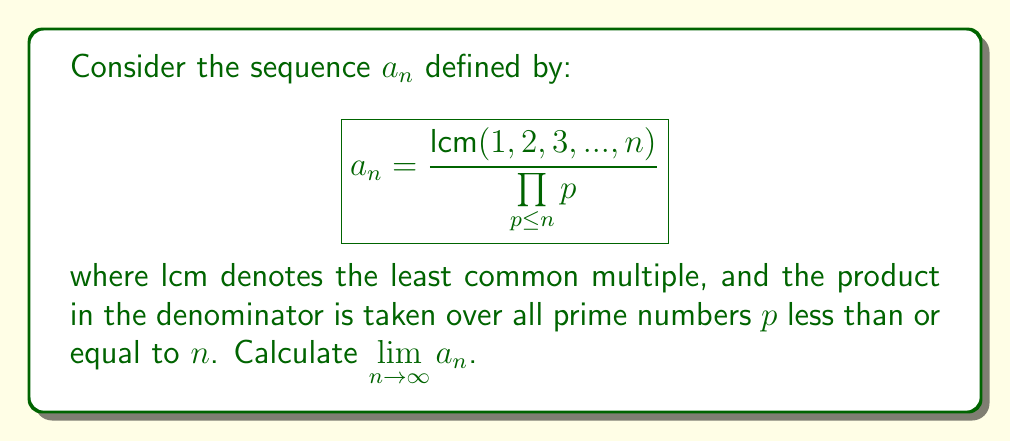Provide a solution to this math problem. To solve this problem, we'll follow these steps:

1) First, let's understand what the sequence represents. The numerator is the LCM of the first $n$ positive integers, and the denominator is the product of all primes up to $n$.

2) A key insight is that the LCM of the first $n$ positive integers can be expressed as:

   $$\text{lcm}(1, 2, 3, ..., n) = \prod_{p \leq n} p^{\lfloor \log_p n \rfloor}$$

   where $\lfloor x \rfloor$ denotes the floor function.

3) Now, we can rewrite our sequence as:

   $$a_n = \frac{\prod_{p \leq n} p^{\lfloor \log_p n \rfloor}}{\prod_{p \leq n} p} = \prod_{p \leq n} p^{\lfloor \log_p n \rfloor - 1}$$

4) For any prime $p$, as $n$ grows large, $\lfloor \log_p n \rfloor - 1$ approaches $\log_p n - 1$.

5) Therefore, we can express the limit as:

   $$\lim_{n \to \infty} a_n = \prod_{p \text{ prime}} p^{\log_p n - 1} = \prod_{p \text{ prime}} \frac{n}{p}$$

6) This infinite product can be rewritten using the fundamental theorem of arithmetic:

   $$\prod_{p \text{ prime}} \frac{n}{p} = \frac{n}{\prod_{p \text{ prime}} p} = \frac{n}{e^{\sum_{p \text{ prime}} \log p}}$$

7) The sum in the denominator is related to the prime number theorem. As $n$ approaches infinity, we have:

   $$\sum_{p \leq n} \log p \sim n$$

8) Therefore, our limit becomes:

   $$\lim_{n \to \infty} a_n = \lim_{n \to \infty} \frac{n}{e^n} = 0$$

Thus, the sequence $a_n$ converges to 0 as $n$ approaches infinity.
Answer: $\lim_{n \to \infty} a_n = 0$ 